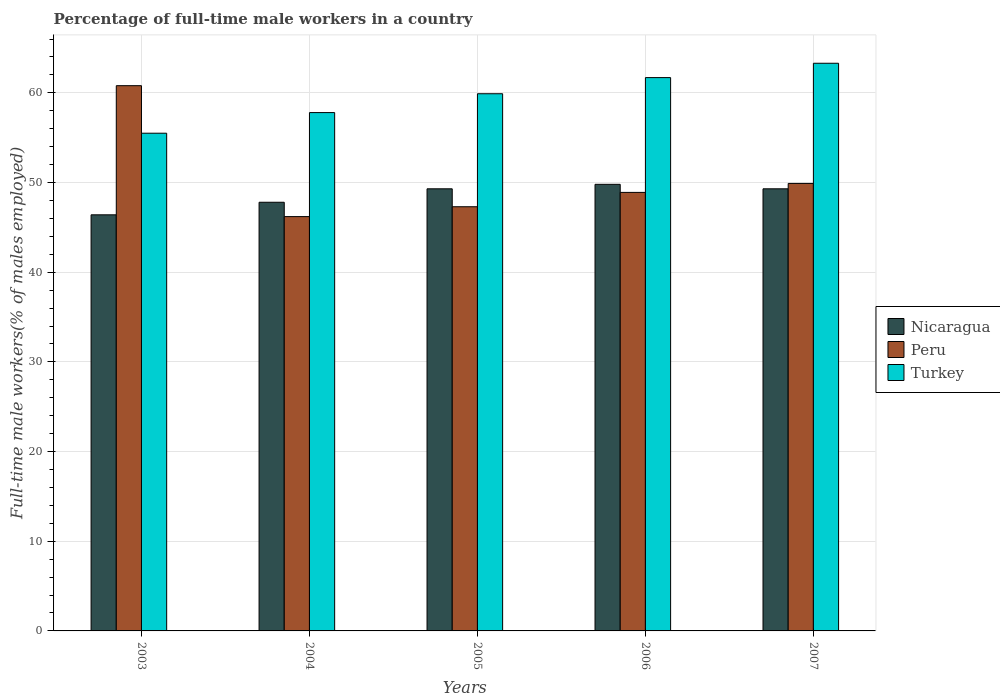How many different coloured bars are there?
Your response must be concise. 3. How many groups of bars are there?
Provide a succinct answer. 5. How many bars are there on the 5th tick from the left?
Give a very brief answer. 3. How many bars are there on the 4th tick from the right?
Give a very brief answer. 3. In how many cases, is the number of bars for a given year not equal to the number of legend labels?
Offer a very short reply. 0. What is the percentage of full-time male workers in Nicaragua in 2004?
Ensure brevity in your answer.  47.8. Across all years, what is the maximum percentage of full-time male workers in Peru?
Your answer should be compact. 60.8. Across all years, what is the minimum percentage of full-time male workers in Peru?
Provide a succinct answer. 46.2. In which year was the percentage of full-time male workers in Turkey maximum?
Your response must be concise. 2007. In which year was the percentage of full-time male workers in Nicaragua minimum?
Provide a succinct answer. 2003. What is the total percentage of full-time male workers in Turkey in the graph?
Make the answer very short. 298.2. What is the difference between the percentage of full-time male workers in Peru in 2004 and that in 2007?
Your answer should be very brief. -3.7. What is the difference between the percentage of full-time male workers in Turkey in 2006 and the percentage of full-time male workers in Peru in 2004?
Your response must be concise. 15.5. What is the average percentage of full-time male workers in Nicaragua per year?
Give a very brief answer. 48.52. In the year 2003, what is the difference between the percentage of full-time male workers in Peru and percentage of full-time male workers in Nicaragua?
Provide a succinct answer. 14.4. In how many years, is the percentage of full-time male workers in Nicaragua greater than 12 %?
Keep it short and to the point. 5. What is the ratio of the percentage of full-time male workers in Peru in 2004 to that in 2007?
Offer a terse response. 0.93. Is the percentage of full-time male workers in Peru in 2003 less than that in 2006?
Give a very brief answer. No. What is the difference between the highest and the second highest percentage of full-time male workers in Turkey?
Make the answer very short. 1.6. What is the difference between the highest and the lowest percentage of full-time male workers in Peru?
Give a very brief answer. 14.6. In how many years, is the percentage of full-time male workers in Peru greater than the average percentage of full-time male workers in Peru taken over all years?
Make the answer very short. 1. How many bars are there?
Your answer should be compact. 15. Are all the bars in the graph horizontal?
Offer a very short reply. No. How many years are there in the graph?
Offer a very short reply. 5. What is the difference between two consecutive major ticks on the Y-axis?
Offer a very short reply. 10. Does the graph contain any zero values?
Give a very brief answer. No. Does the graph contain grids?
Ensure brevity in your answer.  Yes. Where does the legend appear in the graph?
Make the answer very short. Center right. How many legend labels are there?
Provide a short and direct response. 3. What is the title of the graph?
Your answer should be compact. Percentage of full-time male workers in a country. Does "Estonia" appear as one of the legend labels in the graph?
Your response must be concise. No. What is the label or title of the X-axis?
Your response must be concise. Years. What is the label or title of the Y-axis?
Keep it short and to the point. Full-time male workers(% of males employed). What is the Full-time male workers(% of males employed) of Nicaragua in 2003?
Give a very brief answer. 46.4. What is the Full-time male workers(% of males employed) in Peru in 2003?
Make the answer very short. 60.8. What is the Full-time male workers(% of males employed) in Turkey in 2003?
Keep it short and to the point. 55.5. What is the Full-time male workers(% of males employed) of Nicaragua in 2004?
Provide a succinct answer. 47.8. What is the Full-time male workers(% of males employed) in Peru in 2004?
Provide a succinct answer. 46.2. What is the Full-time male workers(% of males employed) in Turkey in 2004?
Your answer should be very brief. 57.8. What is the Full-time male workers(% of males employed) of Nicaragua in 2005?
Give a very brief answer. 49.3. What is the Full-time male workers(% of males employed) in Peru in 2005?
Make the answer very short. 47.3. What is the Full-time male workers(% of males employed) of Turkey in 2005?
Your answer should be very brief. 59.9. What is the Full-time male workers(% of males employed) in Nicaragua in 2006?
Offer a very short reply. 49.8. What is the Full-time male workers(% of males employed) of Peru in 2006?
Your answer should be very brief. 48.9. What is the Full-time male workers(% of males employed) of Turkey in 2006?
Provide a short and direct response. 61.7. What is the Full-time male workers(% of males employed) of Nicaragua in 2007?
Keep it short and to the point. 49.3. What is the Full-time male workers(% of males employed) in Peru in 2007?
Ensure brevity in your answer.  49.9. What is the Full-time male workers(% of males employed) of Turkey in 2007?
Your response must be concise. 63.3. Across all years, what is the maximum Full-time male workers(% of males employed) in Nicaragua?
Your answer should be very brief. 49.8. Across all years, what is the maximum Full-time male workers(% of males employed) of Peru?
Offer a very short reply. 60.8. Across all years, what is the maximum Full-time male workers(% of males employed) in Turkey?
Your answer should be very brief. 63.3. Across all years, what is the minimum Full-time male workers(% of males employed) of Nicaragua?
Provide a short and direct response. 46.4. Across all years, what is the minimum Full-time male workers(% of males employed) in Peru?
Provide a short and direct response. 46.2. Across all years, what is the minimum Full-time male workers(% of males employed) of Turkey?
Your response must be concise. 55.5. What is the total Full-time male workers(% of males employed) in Nicaragua in the graph?
Keep it short and to the point. 242.6. What is the total Full-time male workers(% of males employed) in Peru in the graph?
Provide a short and direct response. 253.1. What is the total Full-time male workers(% of males employed) in Turkey in the graph?
Offer a very short reply. 298.2. What is the difference between the Full-time male workers(% of males employed) in Nicaragua in 2003 and that in 2005?
Your answer should be very brief. -2.9. What is the difference between the Full-time male workers(% of males employed) of Peru in 2003 and that in 2005?
Your answer should be compact. 13.5. What is the difference between the Full-time male workers(% of males employed) in Nicaragua in 2003 and that in 2006?
Keep it short and to the point. -3.4. What is the difference between the Full-time male workers(% of males employed) in Peru in 2003 and that in 2006?
Your answer should be very brief. 11.9. What is the difference between the Full-time male workers(% of males employed) of Turkey in 2003 and that in 2006?
Your response must be concise. -6.2. What is the difference between the Full-time male workers(% of males employed) in Peru in 2003 and that in 2007?
Give a very brief answer. 10.9. What is the difference between the Full-time male workers(% of males employed) in Turkey in 2003 and that in 2007?
Your answer should be very brief. -7.8. What is the difference between the Full-time male workers(% of males employed) of Nicaragua in 2004 and that in 2005?
Keep it short and to the point. -1.5. What is the difference between the Full-time male workers(% of males employed) of Peru in 2004 and that in 2005?
Offer a terse response. -1.1. What is the difference between the Full-time male workers(% of males employed) of Turkey in 2004 and that in 2005?
Ensure brevity in your answer.  -2.1. What is the difference between the Full-time male workers(% of males employed) in Turkey in 2004 and that in 2006?
Make the answer very short. -3.9. What is the difference between the Full-time male workers(% of males employed) of Turkey in 2004 and that in 2007?
Ensure brevity in your answer.  -5.5. What is the difference between the Full-time male workers(% of males employed) of Nicaragua in 2005 and that in 2006?
Your answer should be very brief. -0.5. What is the difference between the Full-time male workers(% of males employed) in Peru in 2005 and that in 2006?
Your answer should be compact. -1.6. What is the difference between the Full-time male workers(% of males employed) in Turkey in 2005 and that in 2006?
Give a very brief answer. -1.8. What is the difference between the Full-time male workers(% of males employed) of Nicaragua in 2005 and that in 2007?
Offer a very short reply. 0. What is the difference between the Full-time male workers(% of males employed) in Turkey in 2005 and that in 2007?
Your response must be concise. -3.4. What is the difference between the Full-time male workers(% of males employed) of Nicaragua in 2006 and that in 2007?
Offer a very short reply. 0.5. What is the difference between the Full-time male workers(% of males employed) of Nicaragua in 2003 and the Full-time male workers(% of males employed) of Turkey in 2005?
Your response must be concise. -13.5. What is the difference between the Full-time male workers(% of males employed) in Nicaragua in 2003 and the Full-time male workers(% of males employed) in Peru in 2006?
Offer a terse response. -2.5. What is the difference between the Full-time male workers(% of males employed) of Nicaragua in 2003 and the Full-time male workers(% of males employed) of Turkey in 2006?
Make the answer very short. -15.3. What is the difference between the Full-time male workers(% of males employed) of Nicaragua in 2003 and the Full-time male workers(% of males employed) of Turkey in 2007?
Your answer should be very brief. -16.9. What is the difference between the Full-time male workers(% of males employed) of Peru in 2003 and the Full-time male workers(% of males employed) of Turkey in 2007?
Provide a short and direct response. -2.5. What is the difference between the Full-time male workers(% of males employed) of Peru in 2004 and the Full-time male workers(% of males employed) of Turkey in 2005?
Make the answer very short. -13.7. What is the difference between the Full-time male workers(% of males employed) in Nicaragua in 2004 and the Full-time male workers(% of males employed) in Turkey in 2006?
Provide a succinct answer. -13.9. What is the difference between the Full-time male workers(% of males employed) in Peru in 2004 and the Full-time male workers(% of males employed) in Turkey in 2006?
Provide a succinct answer. -15.5. What is the difference between the Full-time male workers(% of males employed) of Nicaragua in 2004 and the Full-time male workers(% of males employed) of Peru in 2007?
Give a very brief answer. -2.1. What is the difference between the Full-time male workers(% of males employed) of Nicaragua in 2004 and the Full-time male workers(% of males employed) of Turkey in 2007?
Your response must be concise. -15.5. What is the difference between the Full-time male workers(% of males employed) of Peru in 2004 and the Full-time male workers(% of males employed) of Turkey in 2007?
Make the answer very short. -17.1. What is the difference between the Full-time male workers(% of males employed) in Nicaragua in 2005 and the Full-time male workers(% of males employed) in Peru in 2006?
Keep it short and to the point. 0.4. What is the difference between the Full-time male workers(% of males employed) of Nicaragua in 2005 and the Full-time male workers(% of males employed) of Turkey in 2006?
Offer a very short reply. -12.4. What is the difference between the Full-time male workers(% of males employed) of Peru in 2005 and the Full-time male workers(% of males employed) of Turkey in 2006?
Your response must be concise. -14.4. What is the difference between the Full-time male workers(% of males employed) of Nicaragua in 2005 and the Full-time male workers(% of males employed) of Turkey in 2007?
Your answer should be compact. -14. What is the difference between the Full-time male workers(% of males employed) in Peru in 2005 and the Full-time male workers(% of males employed) in Turkey in 2007?
Ensure brevity in your answer.  -16. What is the difference between the Full-time male workers(% of males employed) of Peru in 2006 and the Full-time male workers(% of males employed) of Turkey in 2007?
Keep it short and to the point. -14.4. What is the average Full-time male workers(% of males employed) in Nicaragua per year?
Your response must be concise. 48.52. What is the average Full-time male workers(% of males employed) in Peru per year?
Ensure brevity in your answer.  50.62. What is the average Full-time male workers(% of males employed) of Turkey per year?
Offer a very short reply. 59.64. In the year 2003, what is the difference between the Full-time male workers(% of males employed) of Nicaragua and Full-time male workers(% of males employed) of Peru?
Make the answer very short. -14.4. In the year 2003, what is the difference between the Full-time male workers(% of males employed) of Peru and Full-time male workers(% of males employed) of Turkey?
Offer a terse response. 5.3. In the year 2004, what is the difference between the Full-time male workers(% of males employed) of Nicaragua and Full-time male workers(% of males employed) of Peru?
Your answer should be compact. 1.6. In the year 2004, what is the difference between the Full-time male workers(% of males employed) of Nicaragua and Full-time male workers(% of males employed) of Turkey?
Offer a terse response. -10. In the year 2004, what is the difference between the Full-time male workers(% of males employed) of Peru and Full-time male workers(% of males employed) of Turkey?
Ensure brevity in your answer.  -11.6. In the year 2005, what is the difference between the Full-time male workers(% of males employed) of Peru and Full-time male workers(% of males employed) of Turkey?
Offer a terse response. -12.6. In the year 2006, what is the difference between the Full-time male workers(% of males employed) in Peru and Full-time male workers(% of males employed) in Turkey?
Make the answer very short. -12.8. In the year 2007, what is the difference between the Full-time male workers(% of males employed) of Nicaragua and Full-time male workers(% of males employed) of Peru?
Your answer should be very brief. -0.6. In the year 2007, what is the difference between the Full-time male workers(% of males employed) in Nicaragua and Full-time male workers(% of males employed) in Turkey?
Make the answer very short. -14. What is the ratio of the Full-time male workers(% of males employed) of Nicaragua in 2003 to that in 2004?
Provide a short and direct response. 0.97. What is the ratio of the Full-time male workers(% of males employed) in Peru in 2003 to that in 2004?
Your answer should be compact. 1.32. What is the ratio of the Full-time male workers(% of males employed) of Turkey in 2003 to that in 2004?
Offer a terse response. 0.96. What is the ratio of the Full-time male workers(% of males employed) of Peru in 2003 to that in 2005?
Keep it short and to the point. 1.29. What is the ratio of the Full-time male workers(% of males employed) in Turkey in 2003 to that in 2005?
Your response must be concise. 0.93. What is the ratio of the Full-time male workers(% of males employed) in Nicaragua in 2003 to that in 2006?
Offer a very short reply. 0.93. What is the ratio of the Full-time male workers(% of males employed) in Peru in 2003 to that in 2006?
Keep it short and to the point. 1.24. What is the ratio of the Full-time male workers(% of males employed) of Turkey in 2003 to that in 2006?
Give a very brief answer. 0.9. What is the ratio of the Full-time male workers(% of males employed) in Peru in 2003 to that in 2007?
Your response must be concise. 1.22. What is the ratio of the Full-time male workers(% of males employed) of Turkey in 2003 to that in 2007?
Ensure brevity in your answer.  0.88. What is the ratio of the Full-time male workers(% of males employed) in Nicaragua in 2004 to that in 2005?
Ensure brevity in your answer.  0.97. What is the ratio of the Full-time male workers(% of males employed) in Peru in 2004 to that in 2005?
Ensure brevity in your answer.  0.98. What is the ratio of the Full-time male workers(% of males employed) of Turkey in 2004 to that in 2005?
Provide a short and direct response. 0.96. What is the ratio of the Full-time male workers(% of males employed) of Nicaragua in 2004 to that in 2006?
Offer a very short reply. 0.96. What is the ratio of the Full-time male workers(% of males employed) of Peru in 2004 to that in 2006?
Your answer should be compact. 0.94. What is the ratio of the Full-time male workers(% of males employed) in Turkey in 2004 to that in 2006?
Your answer should be very brief. 0.94. What is the ratio of the Full-time male workers(% of males employed) of Nicaragua in 2004 to that in 2007?
Provide a succinct answer. 0.97. What is the ratio of the Full-time male workers(% of males employed) of Peru in 2004 to that in 2007?
Give a very brief answer. 0.93. What is the ratio of the Full-time male workers(% of males employed) of Turkey in 2004 to that in 2007?
Make the answer very short. 0.91. What is the ratio of the Full-time male workers(% of males employed) in Peru in 2005 to that in 2006?
Your answer should be compact. 0.97. What is the ratio of the Full-time male workers(% of males employed) of Turkey in 2005 to that in 2006?
Provide a succinct answer. 0.97. What is the ratio of the Full-time male workers(% of males employed) in Peru in 2005 to that in 2007?
Your response must be concise. 0.95. What is the ratio of the Full-time male workers(% of males employed) in Turkey in 2005 to that in 2007?
Give a very brief answer. 0.95. What is the ratio of the Full-time male workers(% of males employed) in Nicaragua in 2006 to that in 2007?
Ensure brevity in your answer.  1.01. What is the ratio of the Full-time male workers(% of males employed) of Turkey in 2006 to that in 2007?
Give a very brief answer. 0.97. What is the difference between the highest and the second highest Full-time male workers(% of males employed) of Peru?
Provide a short and direct response. 10.9. What is the difference between the highest and the second highest Full-time male workers(% of males employed) in Turkey?
Your response must be concise. 1.6. What is the difference between the highest and the lowest Full-time male workers(% of males employed) in Nicaragua?
Ensure brevity in your answer.  3.4. What is the difference between the highest and the lowest Full-time male workers(% of males employed) of Peru?
Provide a succinct answer. 14.6. 